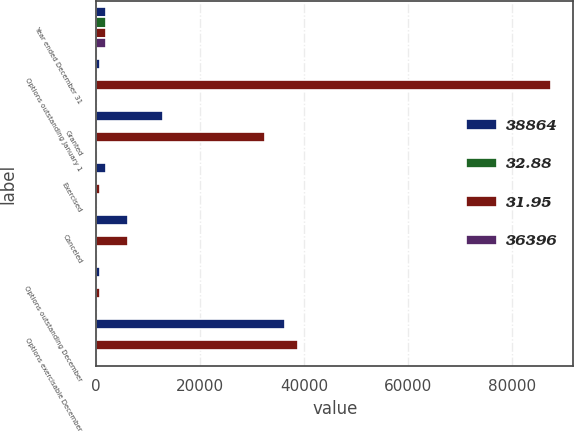<chart> <loc_0><loc_0><loc_500><loc_500><stacked_bar_chart><ecel><fcel>Year ended December 31<fcel>Options outstanding January 1<fcel>Granted<fcel>Exercised<fcel>Canceled<fcel>Options outstanding December<fcel>Options exercisable December<nl><fcel>38864<fcel>2003<fcel>674<fcel>12846<fcel>2007<fcel>6172<fcel>674<fcel>36396<nl><fcel>32.88<fcel>2003<fcel>40.62<fcel>21.87<fcel>13.67<fcel>37.8<fcel>39.11<fcel>32.88<nl><fcel>31.95<fcel>2002<fcel>87393<fcel>32550<fcel>674<fcel>6114<fcel>674<fcel>38864<nl><fcel>36396<fcel>2002<fcel>41.86<fcel>36.85<fcel>15.01<fcel>41.14<fcel>40.62<fcel>31.95<nl></chart> 